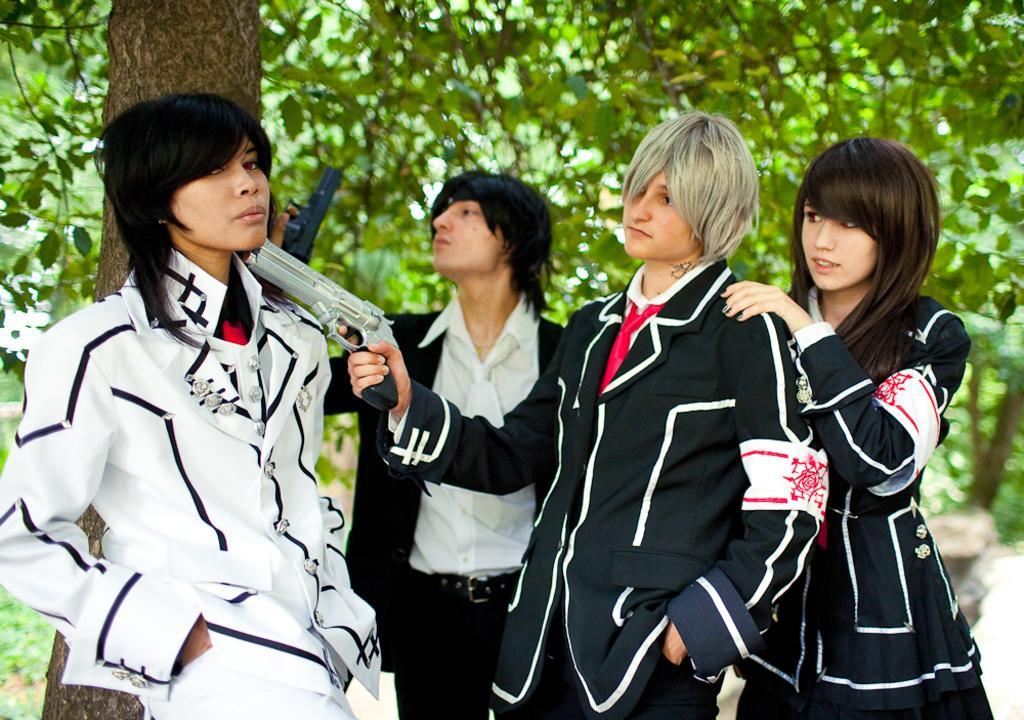Could you give a brief overview of what you see in this image? In the middle of the image few people are standing and holding some guns. Behind them there are some trees. 